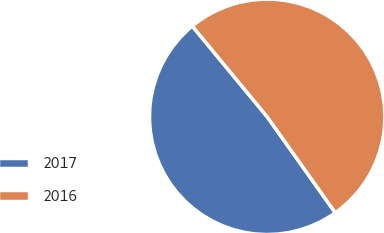Convert chart. <chart><loc_0><loc_0><loc_500><loc_500><pie_chart><fcel>2017<fcel>2016<nl><fcel>48.84%<fcel>51.16%<nl></chart> 